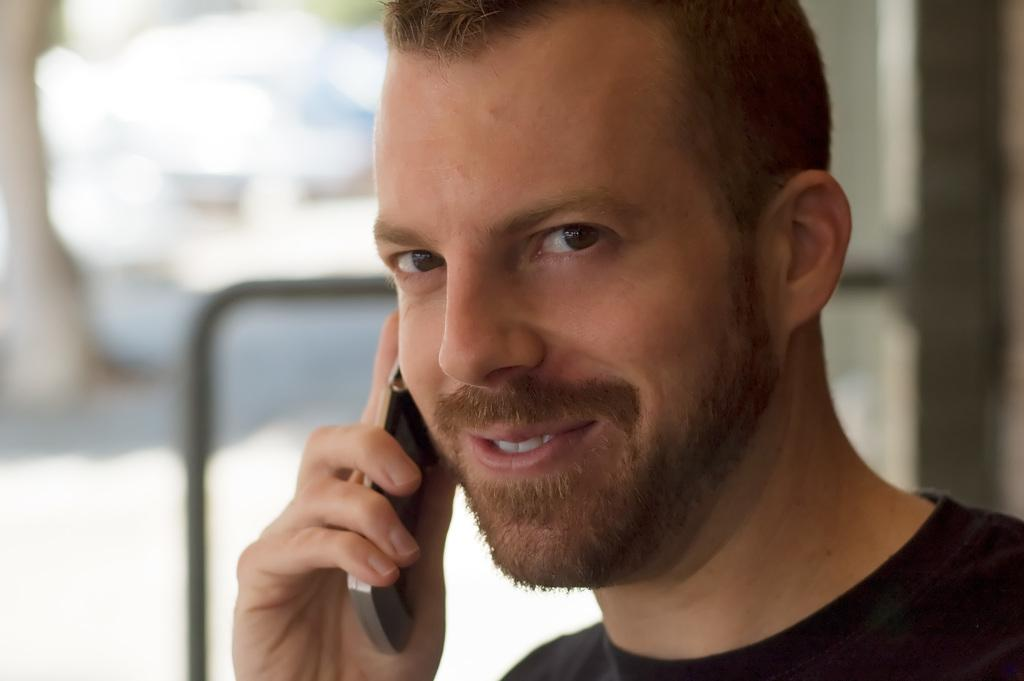What is the main subject of the image? There is a person in the image. What is the person holding in the image? The person is holding a cell phone. Can you describe the background of the image? The background of the image is blurred. What color is the crayon being used by the person in the image? There is no crayon present in the image. How many times does the person turn around in the image? The person does not turn around in the image; they are holding a cell phone. What type of mineral can be seen in the image? There is no mineral, such as quartz, present in the image. 